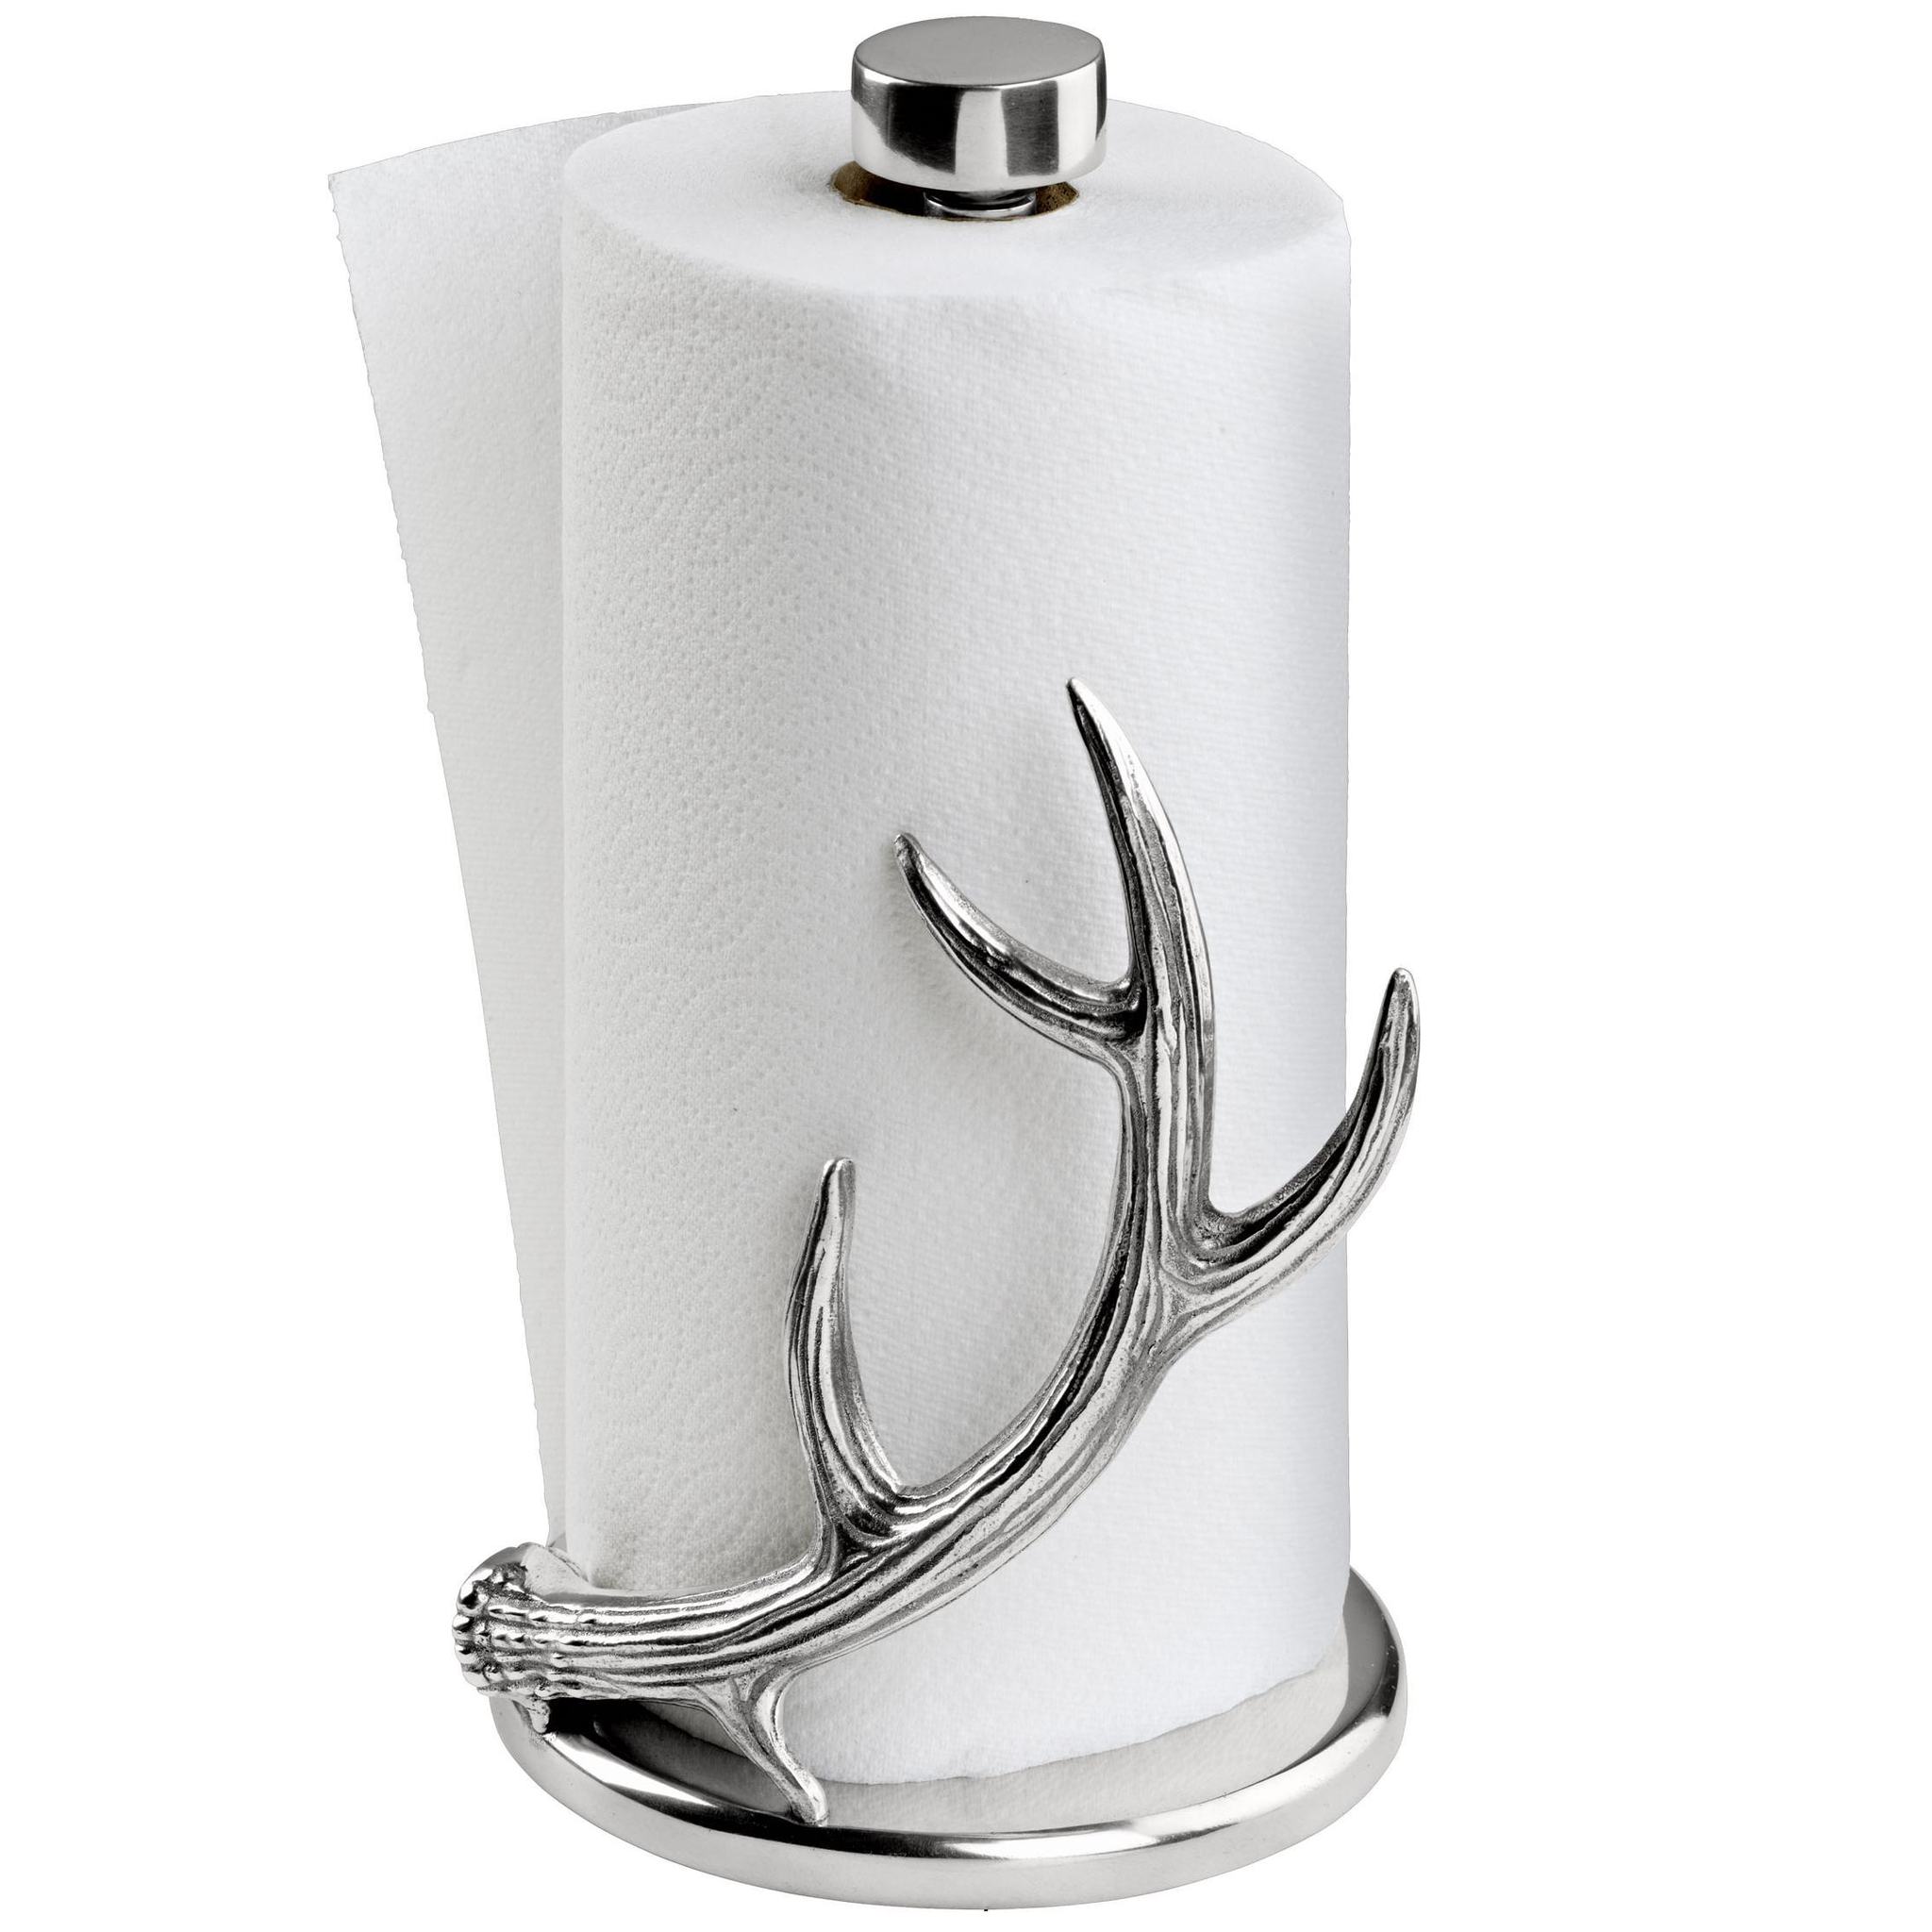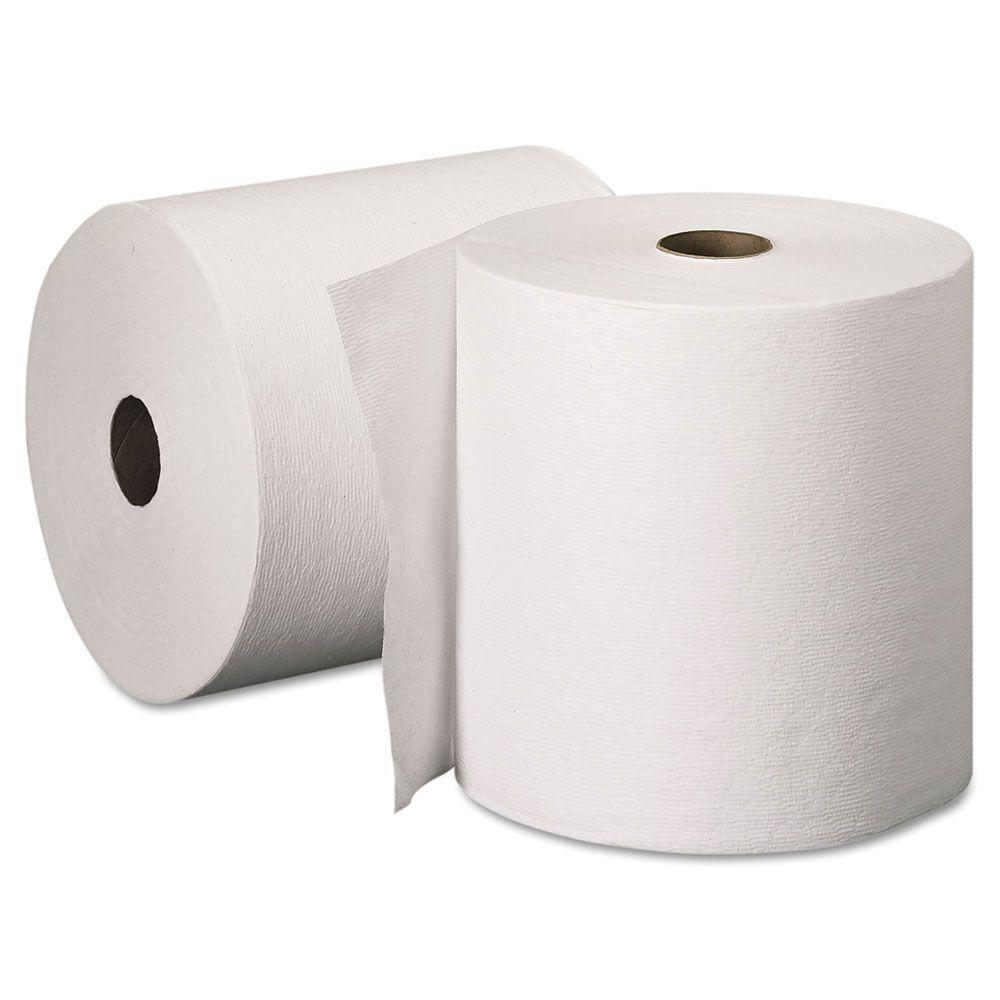The first image is the image on the left, the second image is the image on the right. Analyze the images presented: Is the assertion "A towel roll is held vertically on a stand with a silver base." valid? Answer yes or no. Yes. 